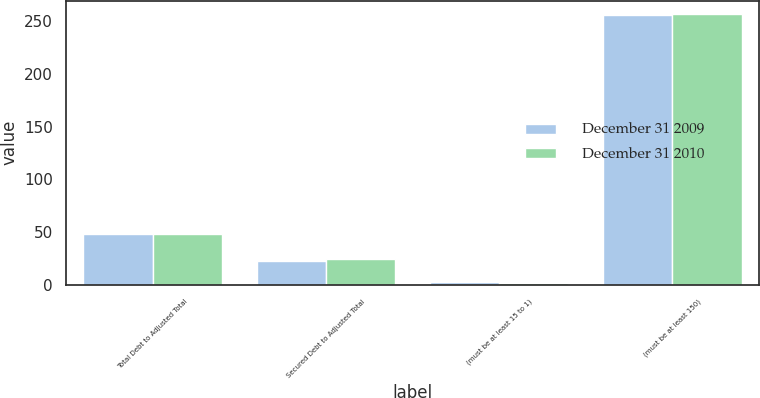Convert chart to OTSL. <chart><loc_0><loc_0><loc_500><loc_500><stacked_bar_chart><ecel><fcel>Total Debt to Adjusted Total<fcel>Secured Debt to Adjusted Total<fcel>(must be at least 15 to 1)<fcel>(must be at least 150)<nl><fcel>December 31 2009<fcel>48.5<fcel>23.2<fcel>2.46<fcel>256<nl><fcel>December 31 2010<fcel>48.8<fcel>24.9<fcel>2.44<fcel>256.5<nl></chart> 